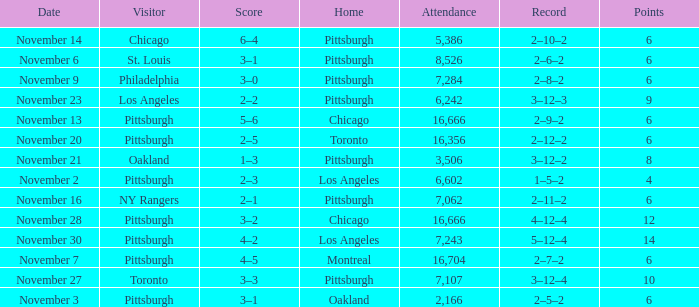What is the lowest amount of points of the game with toronto as the home team? 6.0. 